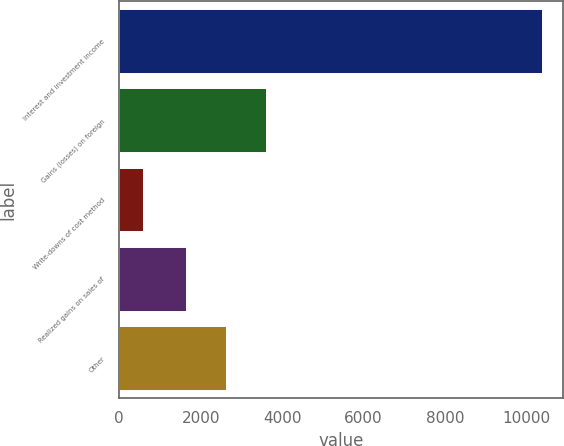Convert chart. <chart><loc_0><loc_0><loc_500><loc_500><bar_chart><fcel>Interest and investment income<fcel>Gains (losses) on foreign<fcel>Write-downs of cost method<fcel>Realized gains on sales of<fcel>Other<nl><fcel>10377<fcel>3600.2<fcel>596<fcel>1644<fcel>2622.1<nl></chart> 